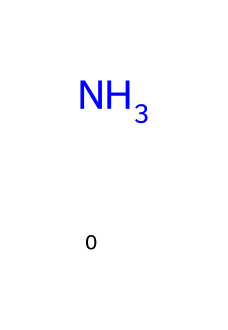What is the chemical name represented by this structure? The structure shows a nitrogen atom (N) without any other atoms or functional groups. This corresponds to ammonia, which is chemically known as nitrogen trihydride.
Answer: ammonia How many hydrogen atoms are present in ammonia? The representation of ammonia is based on a nitrogen atom bonded to three hydrogen atoms (even though they are not explicitly shown in the SMILES). Therefore, there are three hydrogen atoms in ammonia.
Answer: 3 What type of bonding is primarily present in ammonia? In ammonia, the nitrogen forms covalent bonds with the three hydrogen atoms. Covalent bonding involves the sharing of electrons, which is characteristic of the structure.
Answer: covalent What is the molecular formula for ammonia? Using the information from the structure, ammonia consists of one nitrogen atom and three hydrogen atoms, leading to the molecular formula NH3.
Answer: NH3 How many valence electrons does nitrogen have in ammonia? Nitrogen has five valence electrons, which is derived from its position in Group 15 on the periodic table. This is relevant in forming three bonds with hydrogen.
Answer: 5 What describes ammonia's effectiveness as a refrigerant? Ammonia is an effective refrigerant due to its low boiling point and high latent heat of vaporization, which allows it to absorb significant heat during evaporation.
Answer: effective refrigerant 